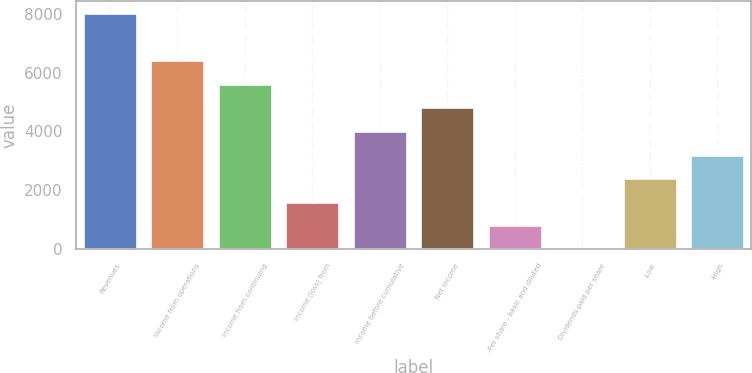Convert chart to OTSL. <chart><loc_0><loc_0><loc_500><loc_500><bar_chart><fcel>Revenues<fcel>Income from operations<fcel>Income from continuing<fcel>Income (loss) from<fcel>Income before cumulative<fcel>Net income<fcel>-Per share - basic and diluted<fcel>Dividends paid per share<fcel>-Low<fcel>-High<nl><fcel>8034<fcel>6427.27<fcel>5623.89<fcel>1606.99<fcel>4017.13<fcel>4820.51<fcel>803.61<fcel>0.23<fcel>2410.37<fcel>3213.75<nl></chart> 